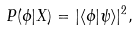Convert formula to latex. <formula><loc_0><loc_0><loc_500><loc_500>P ( \phi | X ) = | \langle \phi | \psi \rangle | ^ { 2 } ,</formula> 